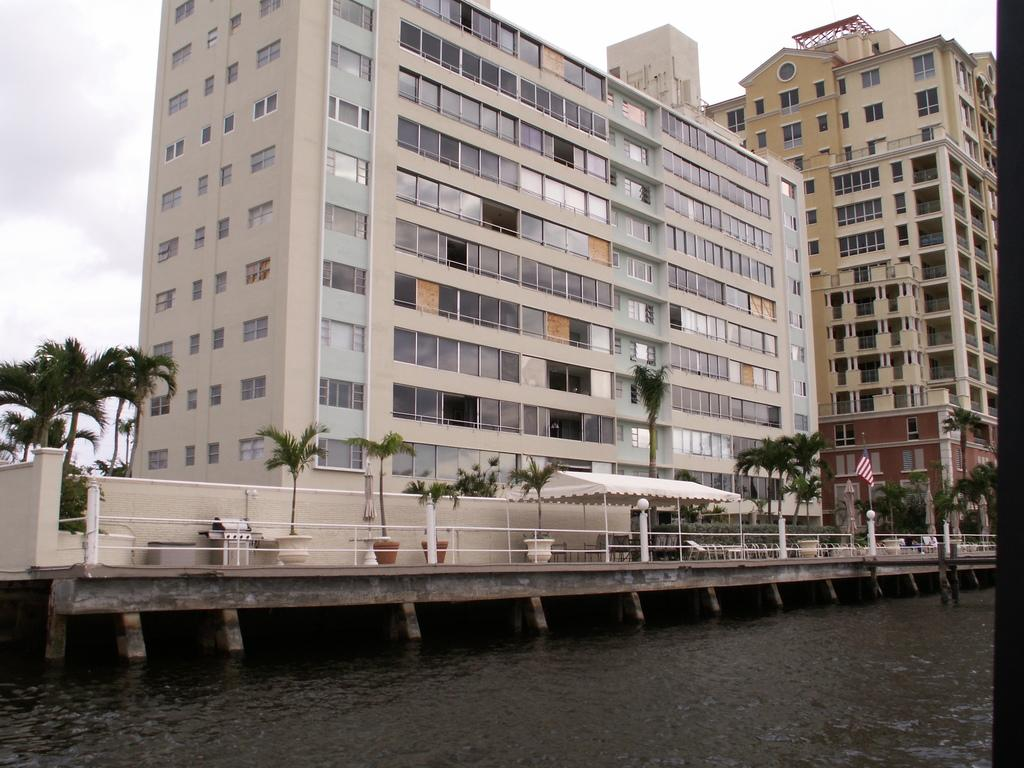What type of structures can be seen in the image? There are buildings in the image. What objects are present that contain plants? There are flower pots in the image. What type of vegetation is visible in the image? There are trees in the image. What is attached to a pole in the image? There is a flag on a pole in the image. What architectural feature is present in the image? There is a bridge in the image. What natural element is visible in the image? There is water visible in the image. What type of barrier is present in the image? There is a fence in the image. What can be seen in the sky in the image? There are clouds in the sky in the image. What type of mist can be seen surrounding the trees in the image? There is no mist present in the image; only clouds can be seen in the sky. What type of straw is used to decorate the flower pots in the image? There is no straw present in the image; only flower pots are visible. 